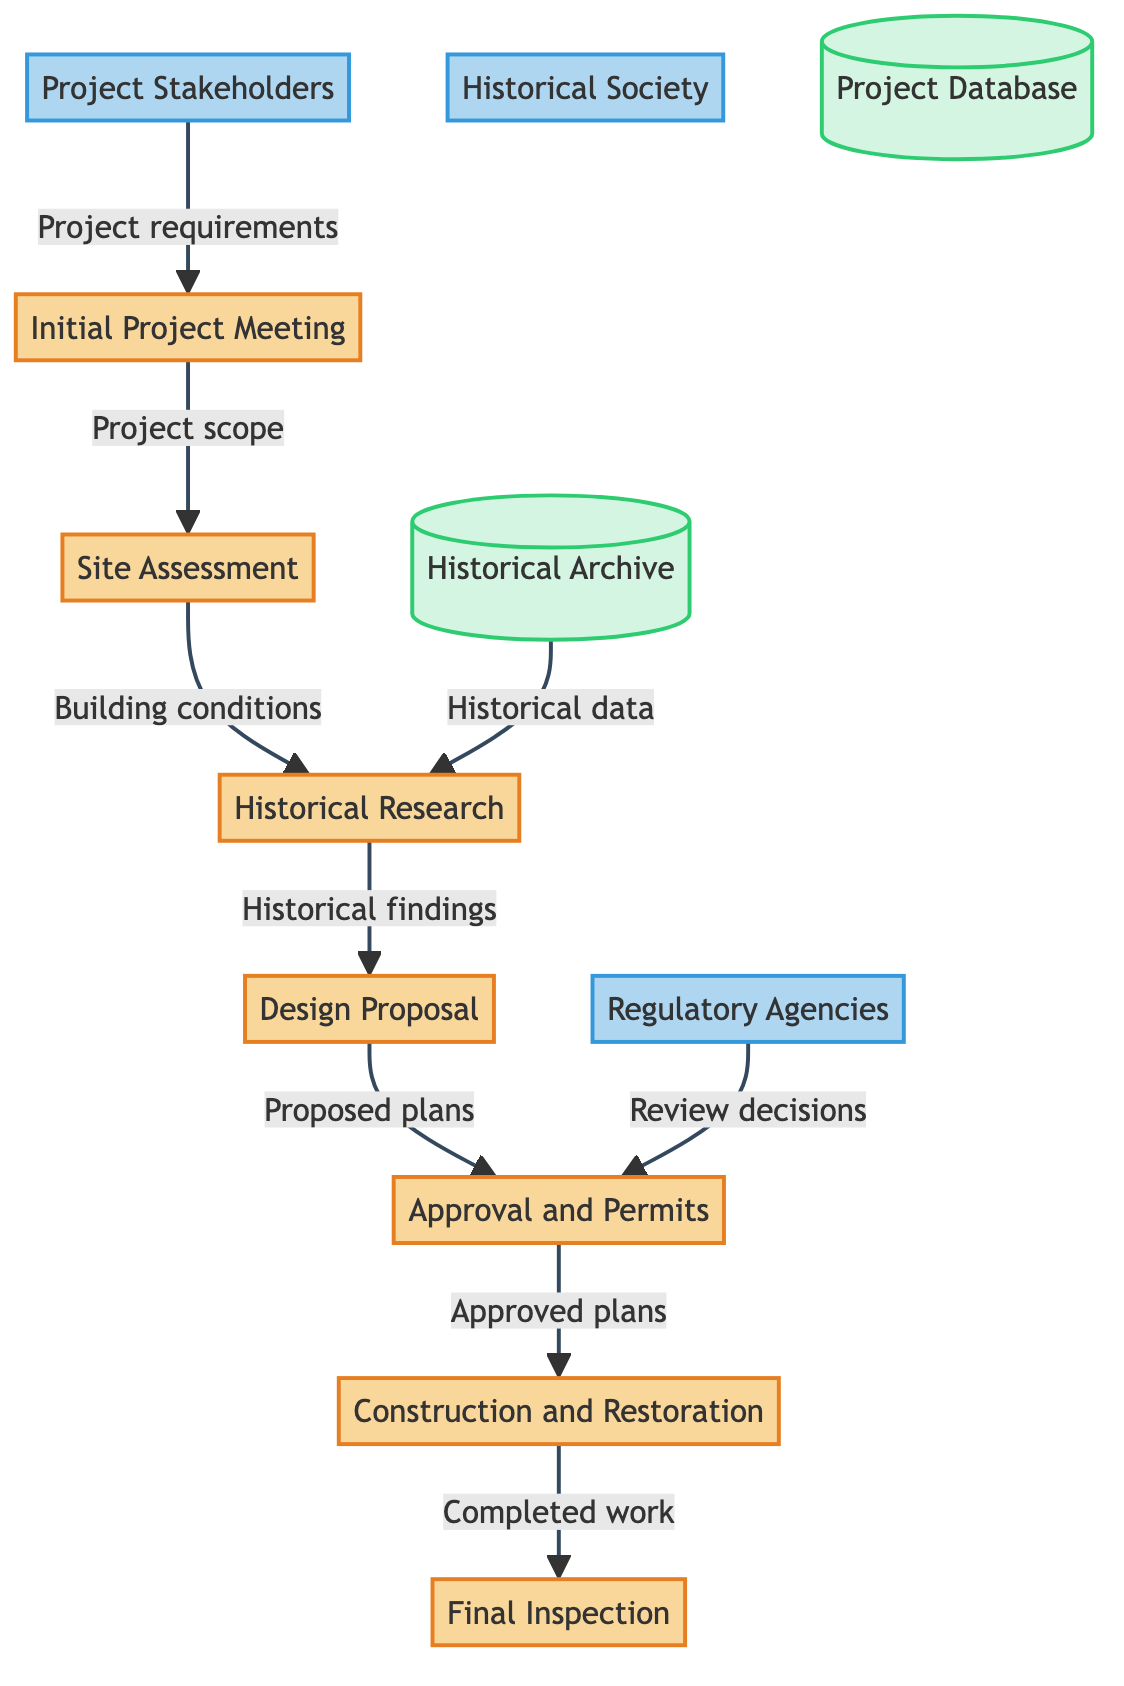What is the first process in the diagram? The first process listed in the diagram is "Initial Project Meeting," which signifies the start of the collaboration.
Answer: Initial Project Meeting How many processes are there in total? There are seven processes represented in the diagram, indicating different stages of the collaboration process.
Answer: 7 What flows into the "Site Assessment" process? The "Site Assessment" process receives data from the "Initial Project Meeting," specifically project scope and goals.
Answer: Project scope Which external entity reviews the "Approval and Permits" process? The "Approval and Permits" process is reviewed by the "Regulatory Agencies," indicating their role in compliance and oversight.
Answer: Regulatory Agencies What is the final process shown in the diagram? The final process in the diagram is "Final Inspection," which represents the closing stage where completed work is ensured to meet standards.
Answer: Final Inspection What data is required for the "Design Proposal"? The "Design Proposal" requires historical findings and recommendations from the "Historical Research" process to ensure alignment with historical significance.
Answer: Historical findings Which datastore provides information for the "Historical Research"? The "Historical Archive" datastore provides historical data and documents that are critical for the "Historical Research" process.
Answer: Historical Archive What does the "Construction and Restoration" process send to the "Final Inspection"? The "Construction and Restoration" process sends the "Completed restoration work" to the "Final Inspection," indicating readiness for review.
Answer: Completed restoration work 